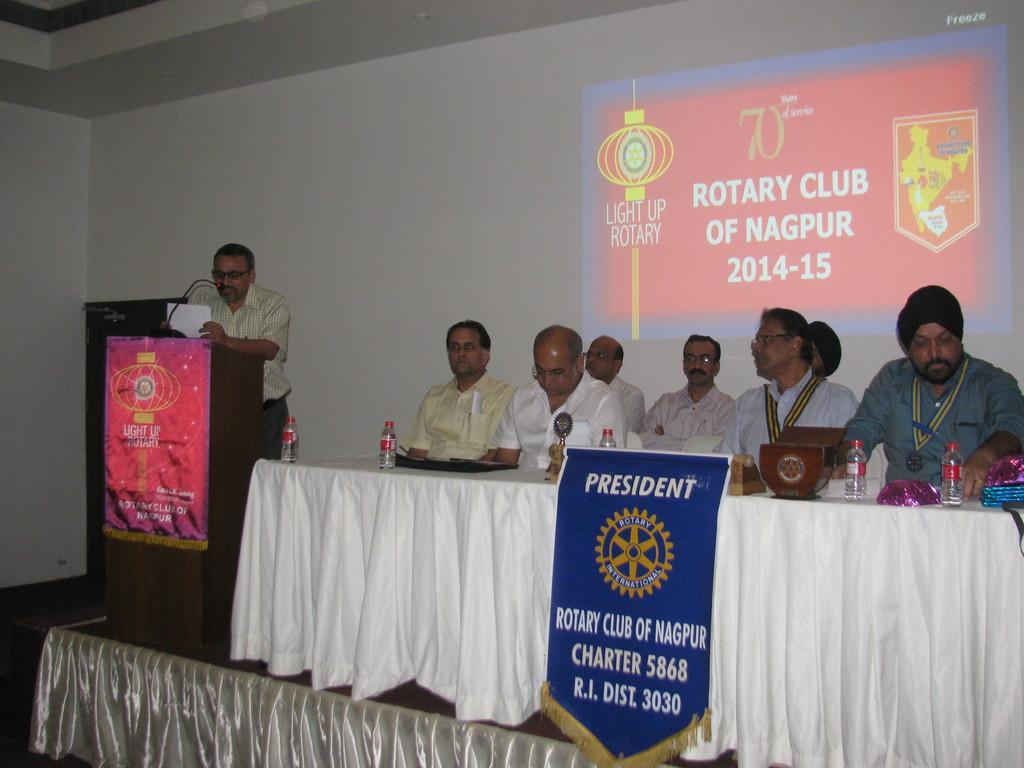Could you give a brief overview of what you see in this image? In this image there is a person standing on the dais and delivering a speech, on the dais there is a mic in front of him, beside the person there are a few other people seated on chairs, in front of them there are bottles of water on the table, behind them there is a screen. 